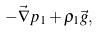<formula> <loc_0><loc_0><loc_500><loc_500>- \vec { \nabla } p _ { 1 } + \rho _ { 1 } \vec { g } ,</formula> 